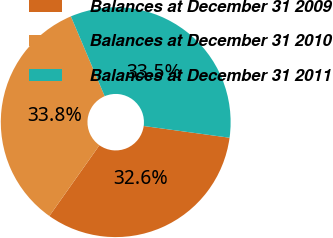Convert chart to OTSL. <chart><loc_0><loc_0><loc_500><loc_500><pie_chart><fcel>Balances at December 31 2009<fcel>Balances at December 31 2010<fcel>Balances at December 31 2011<nl><fcel>32.64%<fcel>33.83%<fcel>33.54%<nl></chart> 